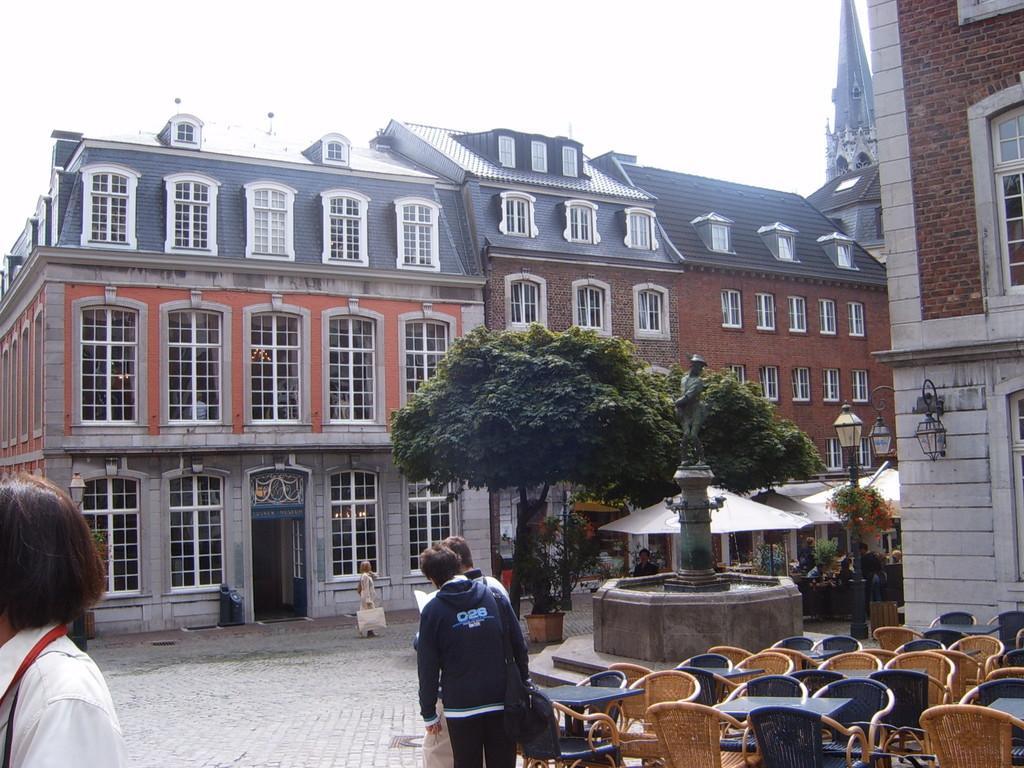How would you summarize this image in a sentence or two? In this image I can see few people are standing. On the right side I can see number of chairs, number of tables and a sculpture. I can also see number of trees, few buildings, few sheds and few lights. 